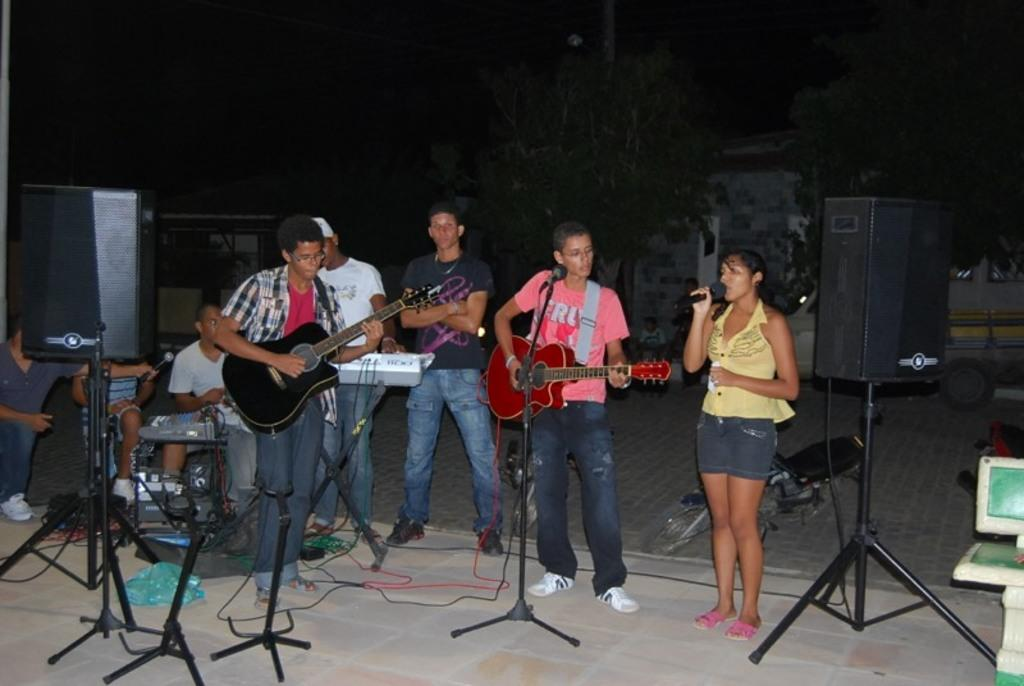What are the people in the center of the image doing? The people in the center of the image are holding guitars. What objects are present on both sides of the image? There are speakers on both the right and left sides of the image. How many boats can be seen in the image? There are no boats present in the image. What type of hair is visible on the people in the image? The provided facts do not mention any details about the people's hair, so it cannot be determined from the image. 